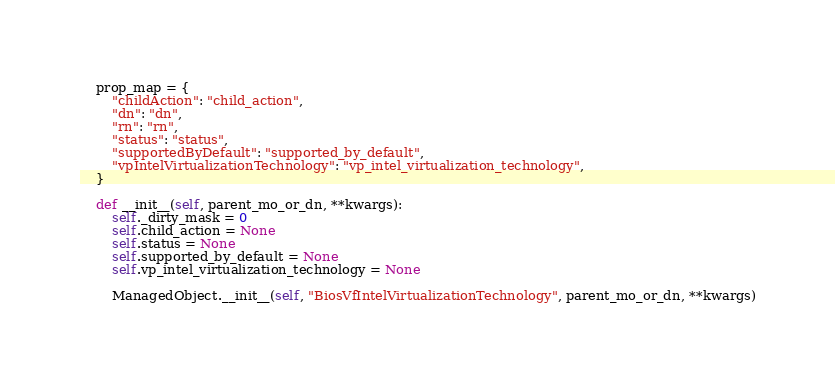<code> <loc_0><loc_0><loc_500><loc_500><_Python_>    prop_map = {
        "childAction": "child_action", 
        "dn": "dn", 
        "rn": "rn", 
        "status": "status", 
        "supportedByDefault": "supported_by_default", 
        "vpIntelVirtualizationTechnology": "vp_intel_virtualization_technology", 
    }

    def __init__(self, parent_mo_or_dn, **kwargs):
        self._dirty_mask = 0
        self.child_action = None
        self.status = None
        self.supported_by_default = None
        self.vp_intel_virtualization_technology = None

        ManagedObject.__init__(self, "BiosVfIntelVirtualizationTechnology", parent_mo_or_dn, **kwargs)

</code> 